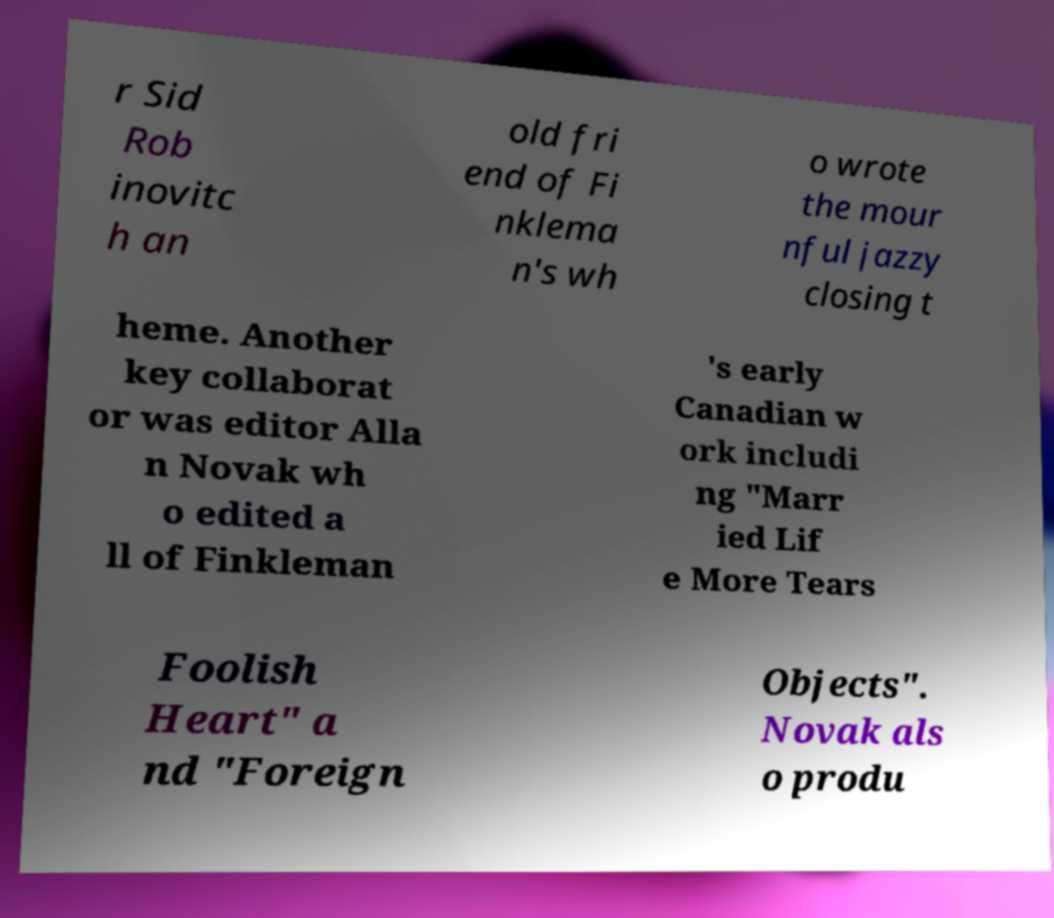Can you accurately transcribe the text from the provided image for me? r Sid Rob inovitc h an old fri end of Fi nklema n's wh o wrote the mour nful jazzy closing t heme. Another key collaborat or was editor Alla n Novak wh o edited a ll of Finkleman 's early Canadian w ork includi ng "Marr ied Lif e More Tears Foolish Heart" a nd "Foreign Objects". Novak als o produ 